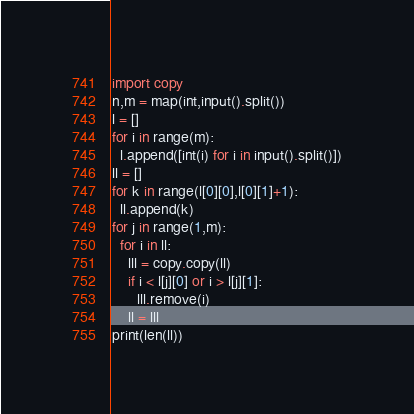Convert code to text. <code><loc_0><loc_0><loc_500><loc_500><_Python_>import copy
n,m = map(int,input().split())
l = []
for i in range(m):
  l.append([int(i) for i in input().split()])
ll = []
for k in range(l[0][0],l[0][1]+1):
  ll.append(k)
for j in range(1,m):
  for i in ll:
    lll = copy.copy(ll)
    if i < l[j][0] or i > l[j][1]:
      lll.remove(i)
    ll = lll
print(len(ll))</code> 